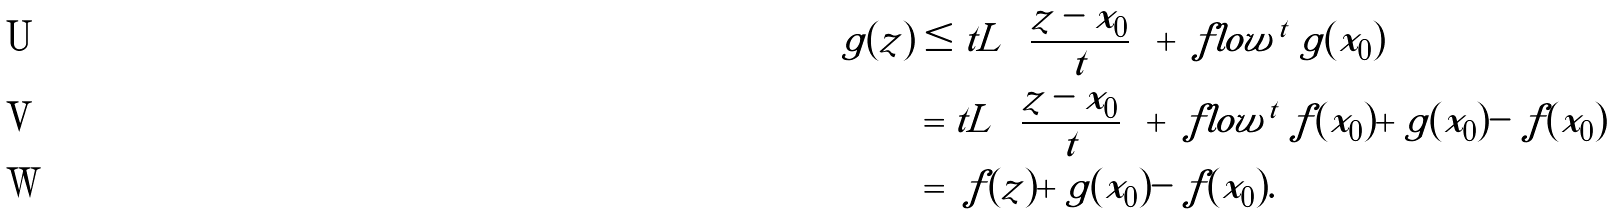Convert formula to latex. <formula><loc_0><loc_0><loc_500><loc_500>\ g ( z ) & \leq t L \left ( \frac { z - x _ { 0 } } { t } \right ) + \ f l o w ^ { t } \ g ( x _ { 0 } ) \\ & = t L \left ( \frac { z - x _ { 0 } } { t } \right ) + \ f l o w ^ { t } \ f ( x _ { 0 } ) + \ g ( x _ { 0 } ) - \ f ( x _ { 0 } ) \\ & = \ f ( z ) + \ g ( x _ { 0 } ) - \ f ( x _ { 0 } ) .</formula> 